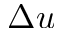Convert formula to latex. <formula><loc_0><loc_0><loc_500><loc_500>\Delta u</formula> 